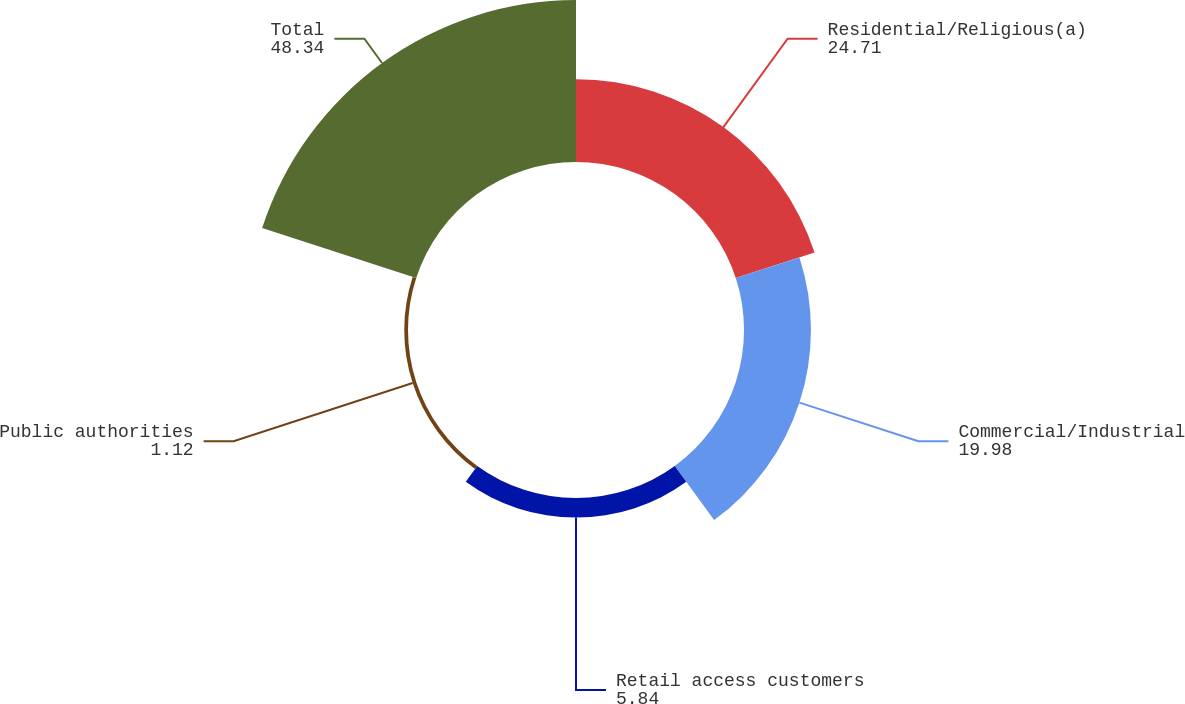Convert chart. <chart><loc_0><loc_0><loc_500><loc_500><pie_chart><fcel>Residential/Religious(a)<fcel>Commercial/Industrial<fcel>Retail access customers<fcel>Public authorities<fcel>Total<nl><fcel>24.71%<fcel>19.98%<fcel>5.84%<fcel>1.12%<fcel>48.34%<nl></chart> 